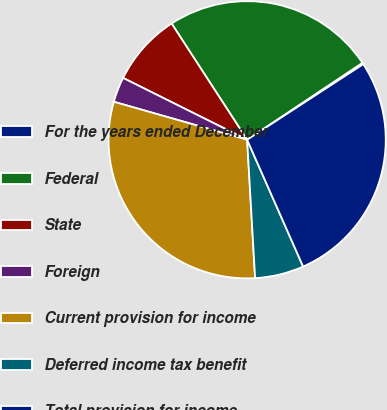<chart> <loc_0><loc_0><loc_500><loc_500><pie_chart><fcel>For the years ended December<fcel>Federal<fcel>State<fcel>Foreign<fcel>Current provision for income<fcel>Deferred income tax benefit<fcel>Total provision for income<nl><fcel>0.18%<fcel>24.81%<fcel>8.47%<fcel>2.94%<fcel>30.34%<fcel>5.7%<fcel>27.57%<nl></chart> 